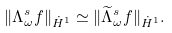<formula> <loc_0><loc_0><loc_500><loc_500>\| \Lambda _ { \omega } ^ { s } f \| _ { \dot { H } ^ { 1 } } \simeq \| \widetilde { \Lambda } _ { \omega } ^ { s } f \| _ { \dot { H } ^ { 1 } } .</formula> 